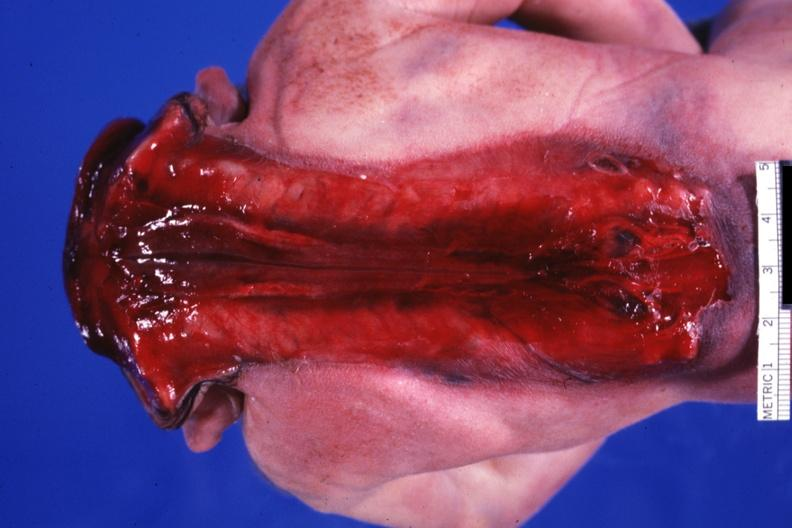does typical tuberculous exudate show posterior view of whole body to buttocks?
Answer the question using a single word or phrase. No 